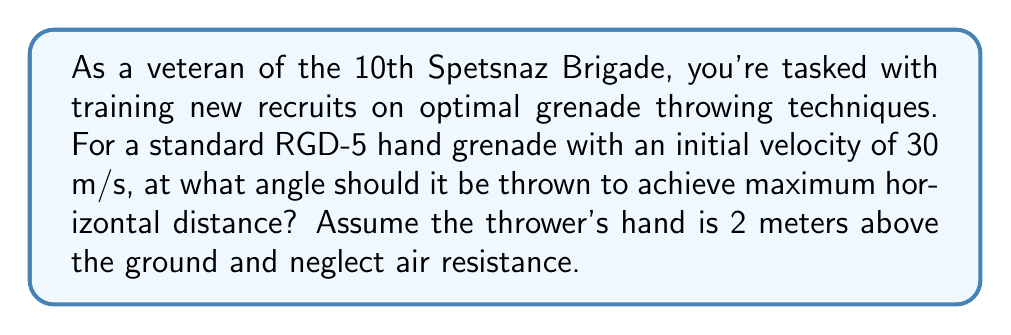Solve this math problem. To solve this problem, we'll use the principles of projectile motion and the equations for the range of a projectile.

1) The range equation for a projectile launched from height $h$ with initial velocity $v_0$ at an angle $\theta$ to the horizontal is:

   $$R = \frac{v_0\cos\theta}{g}\left(v_0\sin\theta + \sqrt{(v_0\sin\theta)^2 + 2gh}\right)$$

   Where $g$ is the acceleration due to gravity (9.8 m/s²).

2) To find the angle for maximum range, we need to differentiate $R$ with respect to $\theta$ and set it to zero. However, this leads to a complex equation.

3) For projectiles launched from ground level ($h=0$), the optimal angle is always 45°. When launched from a height, the optimal angle is slightly less than 45°.

4) For small heights relative to the range (which is typically the case for hand grenades), we can approximate the optimal angle using:

   $$\theta_{opt} \approx 45° - \frac{1}{2}\arctan\left(\frac{4h}{R_0}\right)$$

   Where $R_0$ is the range when thrown at 45° from ground level:

   $$R_0 = \frac{v_0^2}{g}$$

5) Calculate $R_0$:
   $$R_0 = \frac{(30\text{ m/s})^2}{9.8\text{ m/s}^2} = 91.84\text{ m}$$

6) Now calculate $\theta_{opt}$:
   $$\theta_{opt} \approx 45° - \frac{1}{2}\arctan\left(\frac{4(2\text{ m})}{91.84\text{ m}}\right) = 44.5°$$

Therefore, the optimal angle for maximum horizontal distance is approximately 44.5°.
Answer: The optimal angle for throwing the grenade to achieve maximum horizontal distance is approximately 44.5°. 